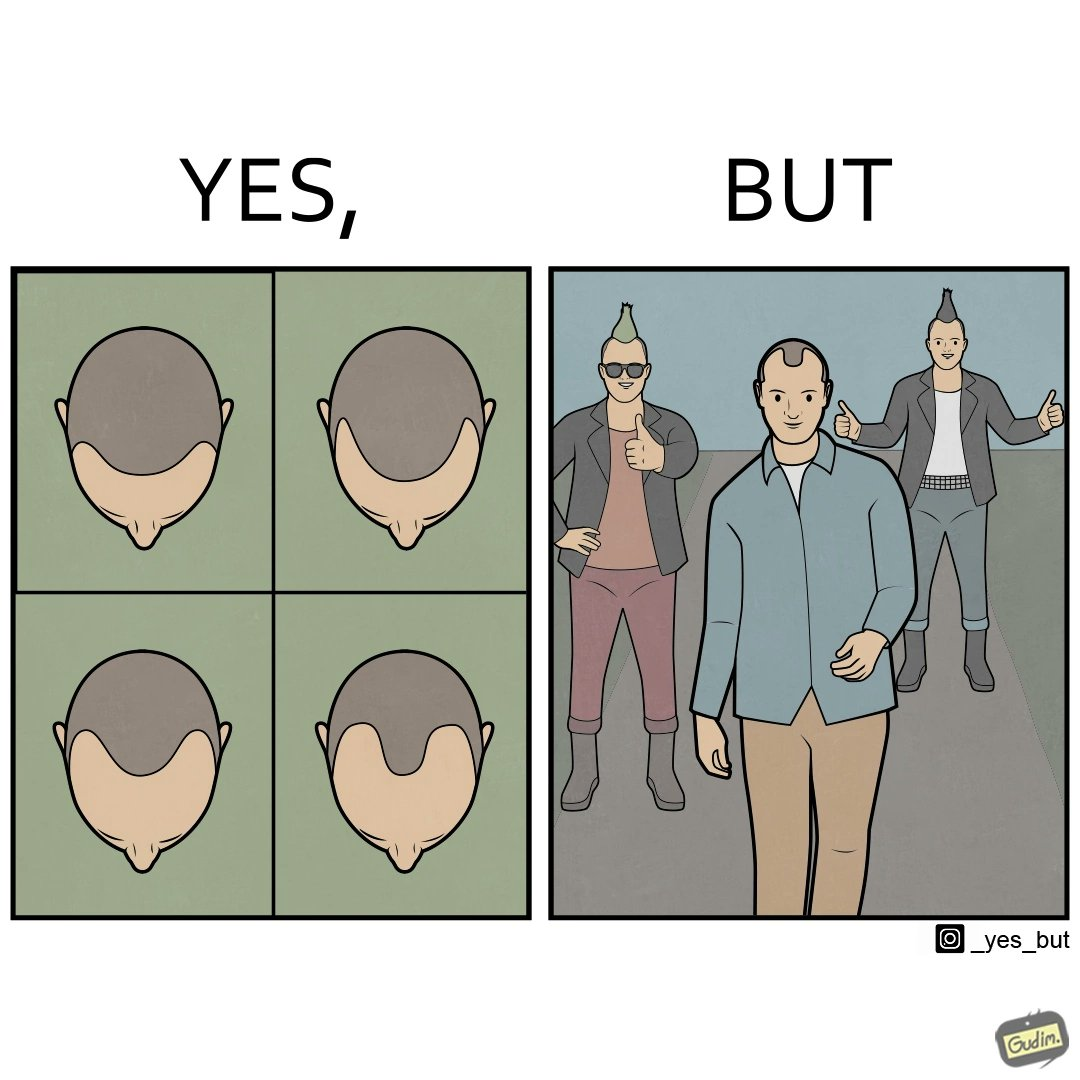Why is this image considered satirical? The images are funny since they show how new hairstyles are closely resembling pattern baldness 